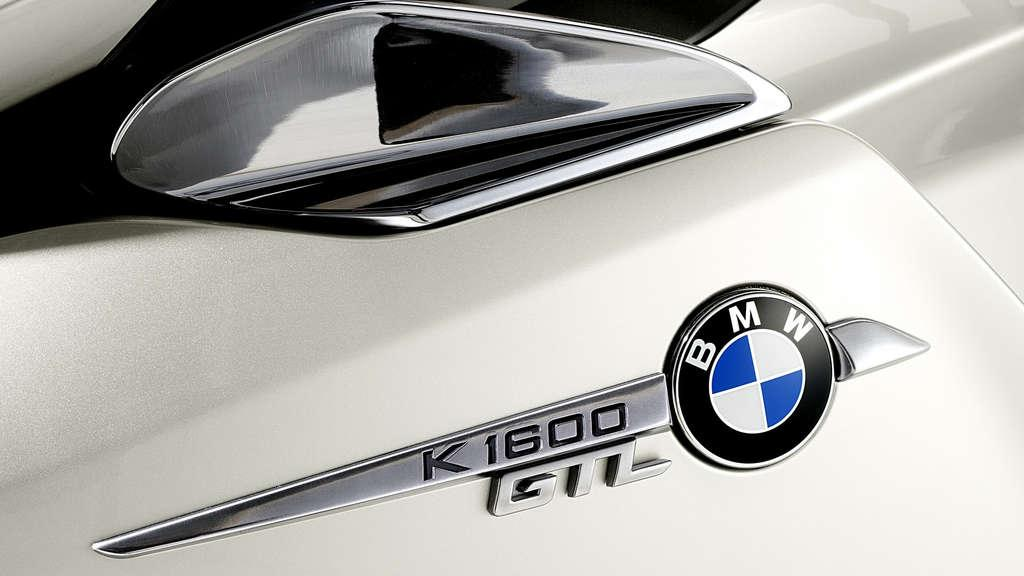What type of car is in the image? There is a BMW car in the image. Is the bear taking a vacation in the BMW car in the image? There is no bear present in the image, and therefore no indication of a vacation. 